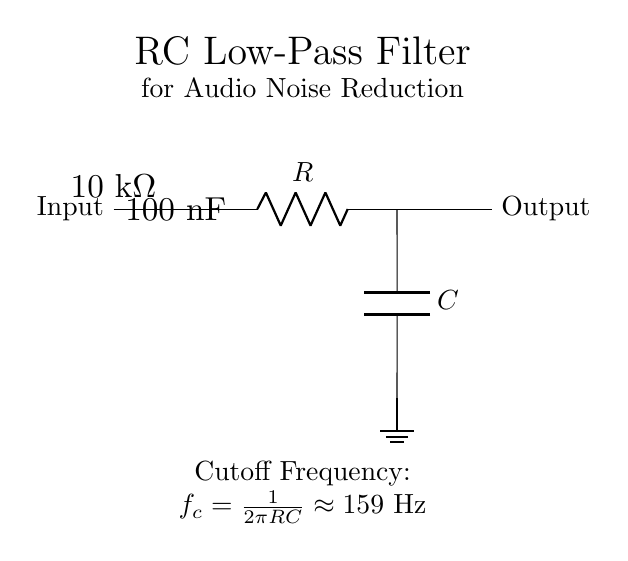What type of circuit is shown? The circuit is an RC low-pass filter, which is designed to allow low-frequency signals to pass while attenuating high-frequency noise. The components and configuration indicate its purpose.
Answer: RC low-pass filter What is the resistance value in the circuit? The resistance value is specified next to the resistor component in the circuit diagram, which is labeled as ten kilohms.
Answer: ten kilohms What is the capacitance value used in this filter? The capacitance value is found beside the capacitor, noted as one hundred nanofarads. This indicates the amount of capacitance in the circuit.
Answer: one hundred nanofarads What is the cutoff frequency of this filter? The cutoff frequency is calculated using the provided formula \(f_c = \frac{1}{2\pi RC}\), which relates the resistor and capacitor values. Applying the values gives a frequency of approximately one hundred fifty-nine hertz.
Answer: one hundred fifty-nine hertz Why is this circuit used for audio systems? This circuit reduces high-frequency noise, which can interfere with audio signals, thereby improving sound quality. Low-pass filters effectively remove unwanted signals above the cutoff frequency.
Answer: to reduce high-frequency noise What is the role of the capacitor in this circuit? The capacitor in the RC low-pass filter is responsible for blocking high-frequency signals while allowing low-frequency signals to pass through, thus contributing to the filtering process.
Answer: to block high-frequency signals Where is the ground connection in the circuit? The ground connection is shown at the bottom of the capacitor component, indicating that this is the reference point for the circuit's electrical potential.
Answer: at the bottom of the capacitor 